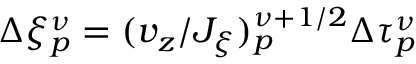<formula> <loc_0><loc_0><loc_500><loc_500>\Delta \xi _ { p } ^ { \nu } = ( v _ { z } / J _ { \xi } ) _ { p } ^ { \nu + 1 / 2 } \Delta \tau _ { p } ^ { \nu }</formula> 